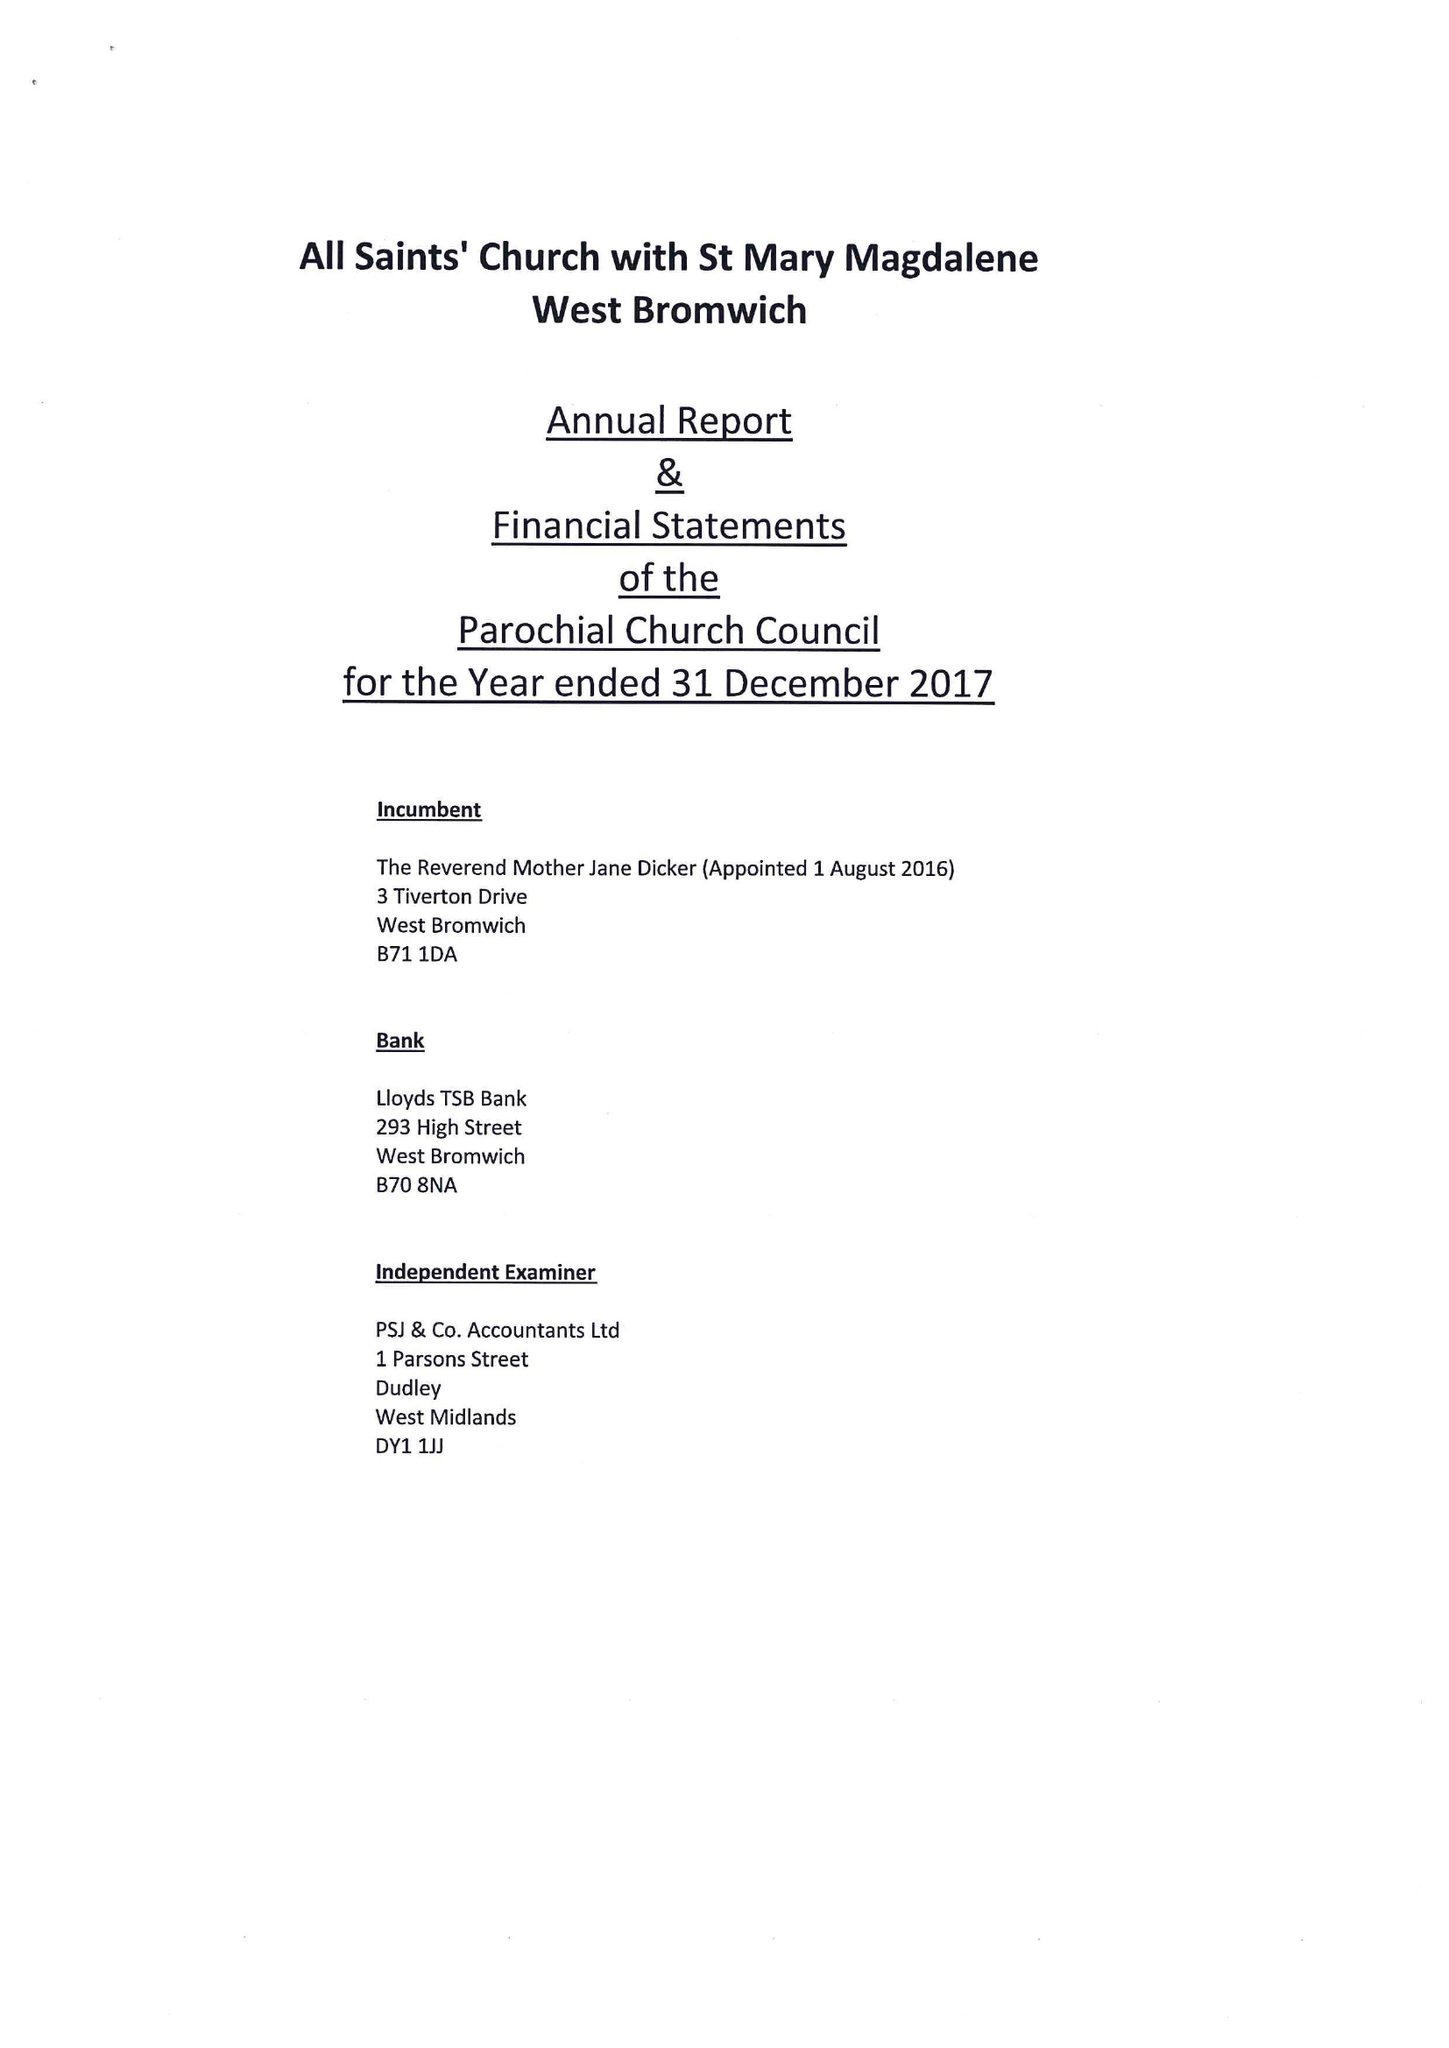What is the value for the address__post_town?
Answer the question using a single word or phrase. BIRMINGHAM 